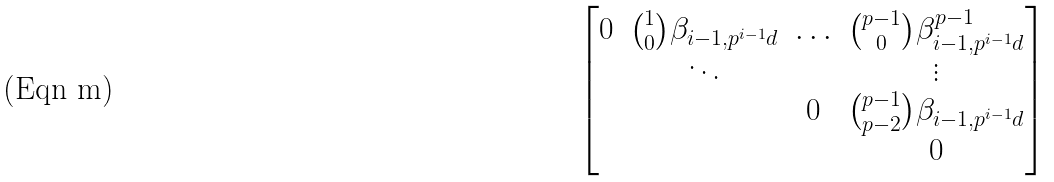<formula> <loc_0><loc_0><loc_500><loc_500>\begin{bmatrix} 0 & \binom { 1 } { 0 } \beta _ { i - 1 , p ^ { i - 1 } d } & \hdots & \binom { p - 1 } { 0 } \beta _ { i - 1 , p ^ { i - 1 } d } ^ { p - 1 } \\ & \ddots & & \vdots \\ & & 0 & \binom { p - 1 } { p - 2 } \beta _ { i - 1 , p ^ { i - 1 } d } \\ & & & 0 \end{bmatrix}</formula> 